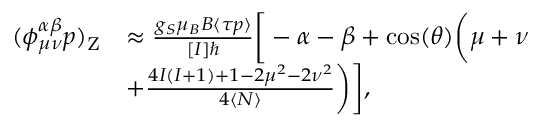Convert formula to latex. <formula><loc_0><loc_0><loc_500><loc_500>\begin{array} { r l } { ( \phi _ { \mu \nu } ^ { \alpha \beta } p ) _ { Z } } & { \approx \frac { g _ { S } \mu _ { B } B \langle \tau p \rangle } { [ I ] } \left [ - \alpha - \beta + \cos ( \theta ) \left ( \mu + \nu } \\ & { + \frac { 4 I ( I + 1 ) + 1 - 2 \mu ^ { 2 } - 2 \nu ^ { 2 } } { 4 \langle N \rangle } \right ) \right ] , } \end{array}</formula> 